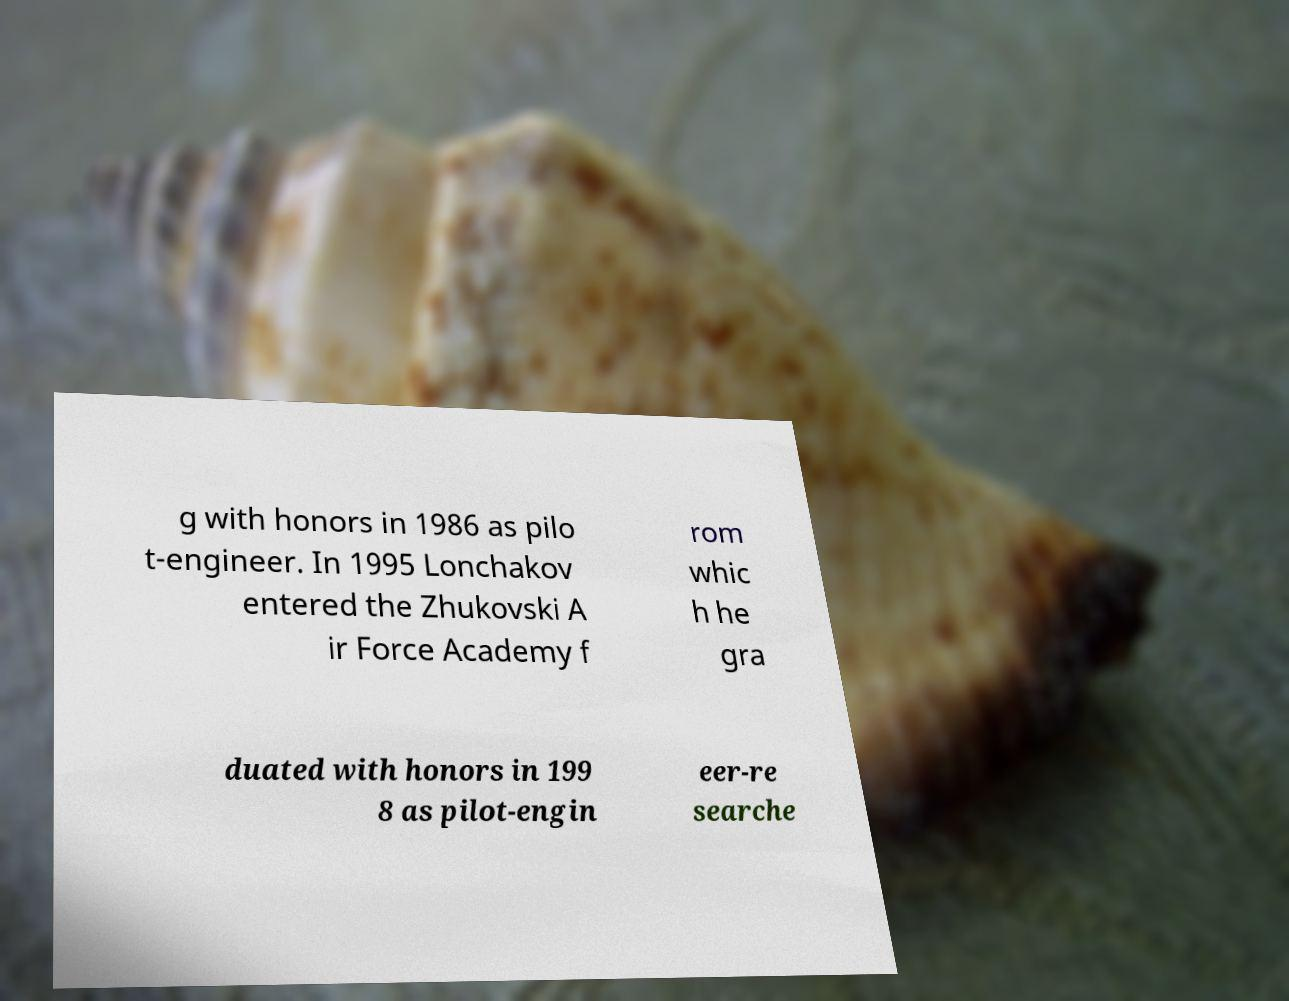Could you extract and type out the text from this image? g with honors in 1986 as pilo t-engineer. In 1995 Lonchakov entered the Zhukovski A ir Force Academy f rom whic h he gra duated with honors in 199 8 as pilot-engin eer-re searche 